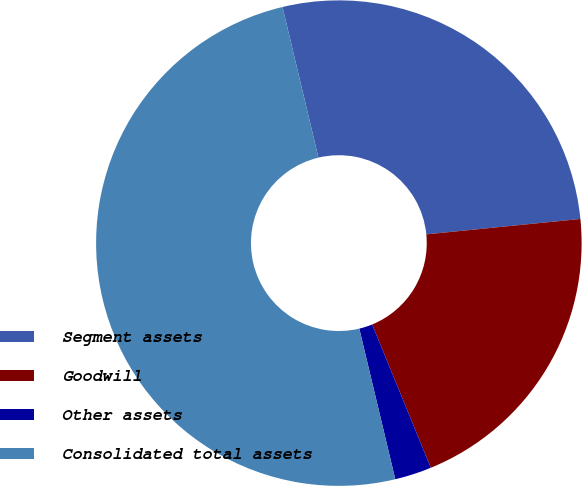Convert chart to OTSL. <chart><loc_0><loc_0><loc_500><loc_500><pie_chart><fcel>Segment assets<fcel>Goodwill<fcel>Other assets<fcel>Consolidated total assets<nl><fcel>27.14%<fcel>20.4%<fcel>2.45%<fcel>50.0%<nl></chart> 